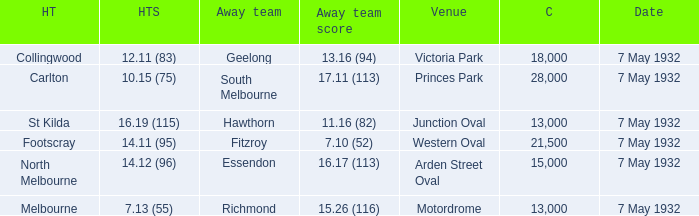What is the offsite team with a spectator count above 13,000, and a home team score of 1 Geelong. Could you parse the entire table? {'header': ['HT', 'HTS', 'Away team', 'Away team score', 'Venue', 'C', 'Date'], 'rows': [['Collingwood', '12.11 (83)', 'Geelong', '13.16 (94)', 'Victoria Park', '18,000', '7 May 1932'], ['Carlton', '10.15 (75)', 'South Melbourne', '17.11 (113)', 'Princes Park', '28,000', '7 May 1932'], ['St Kilda', '16.19 (115)', 'Hawthorn', '11.16 (82)', 'Junction Oval', '13,000', '7 May 1932'], ['Footscray', '14.11 (95)', 'Fitzroy', '7.10 (52)', 'Western Oval', '21,500', '7 May 1932'], ['North Melbourne', '14.12 (96)', 'Essendon', '16.17 (113)', 'Arden Street Oval', '15,000', '7 May 1932'], ['Melbourne', '7.13 (55)', 'Richmond', '15.26 (116)', 'Motordrome', '13,000', '7 May 1932']]} 